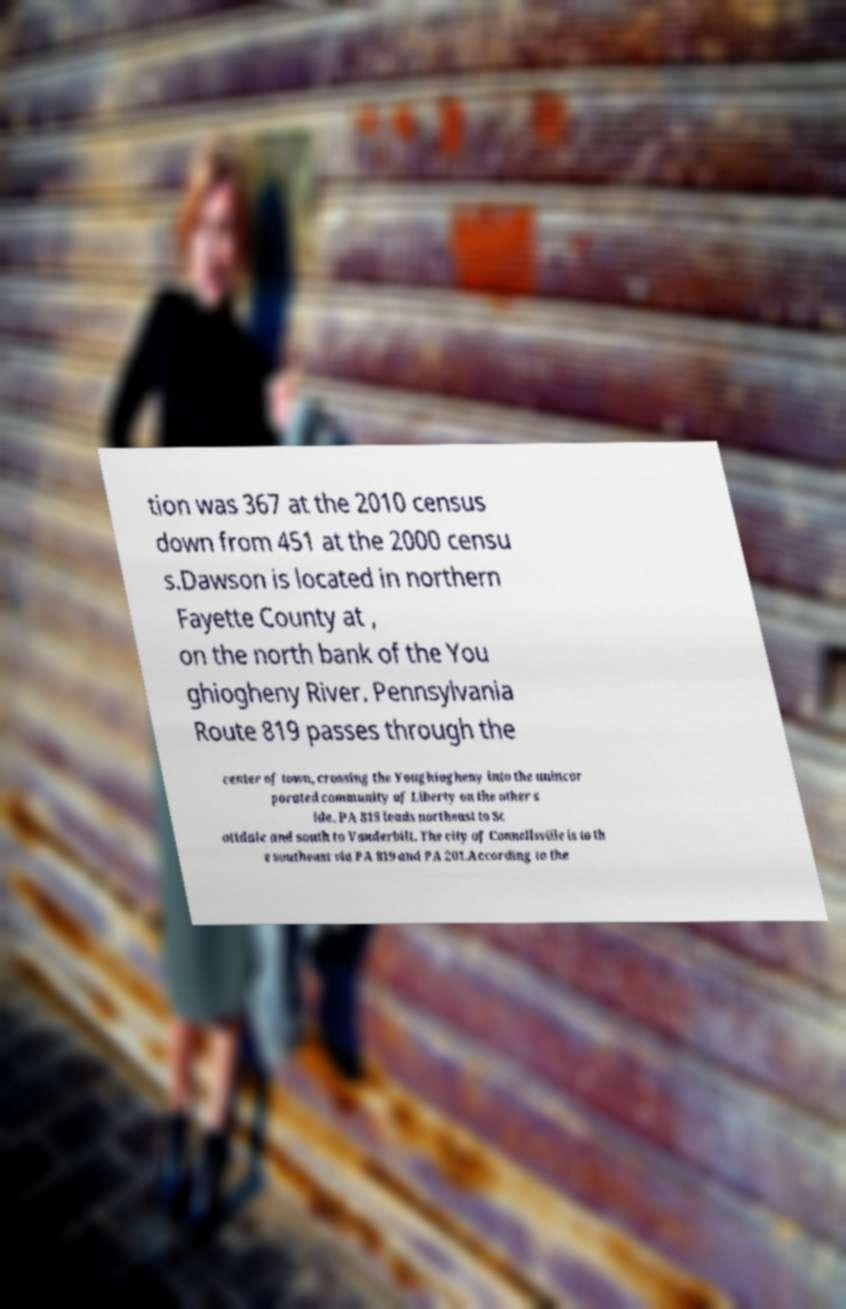Could you extract and type out the text from this image? tion was 367 at the 2010 census down from 451 at the 2000 censu s.Dawson is located in northern Fayette County at , on the north bank of the You ghiogheny River. Pennsylvania Route 819 passes through the center of town, crossing the Youghiogheny into the unincor porated community of Liberty on the other s ide. PA 819 leads northeast to Sc ottdale and south to Vanderbilt. The city of Connellsville is to th e southeast via PA 819 and PA 201.According to the 